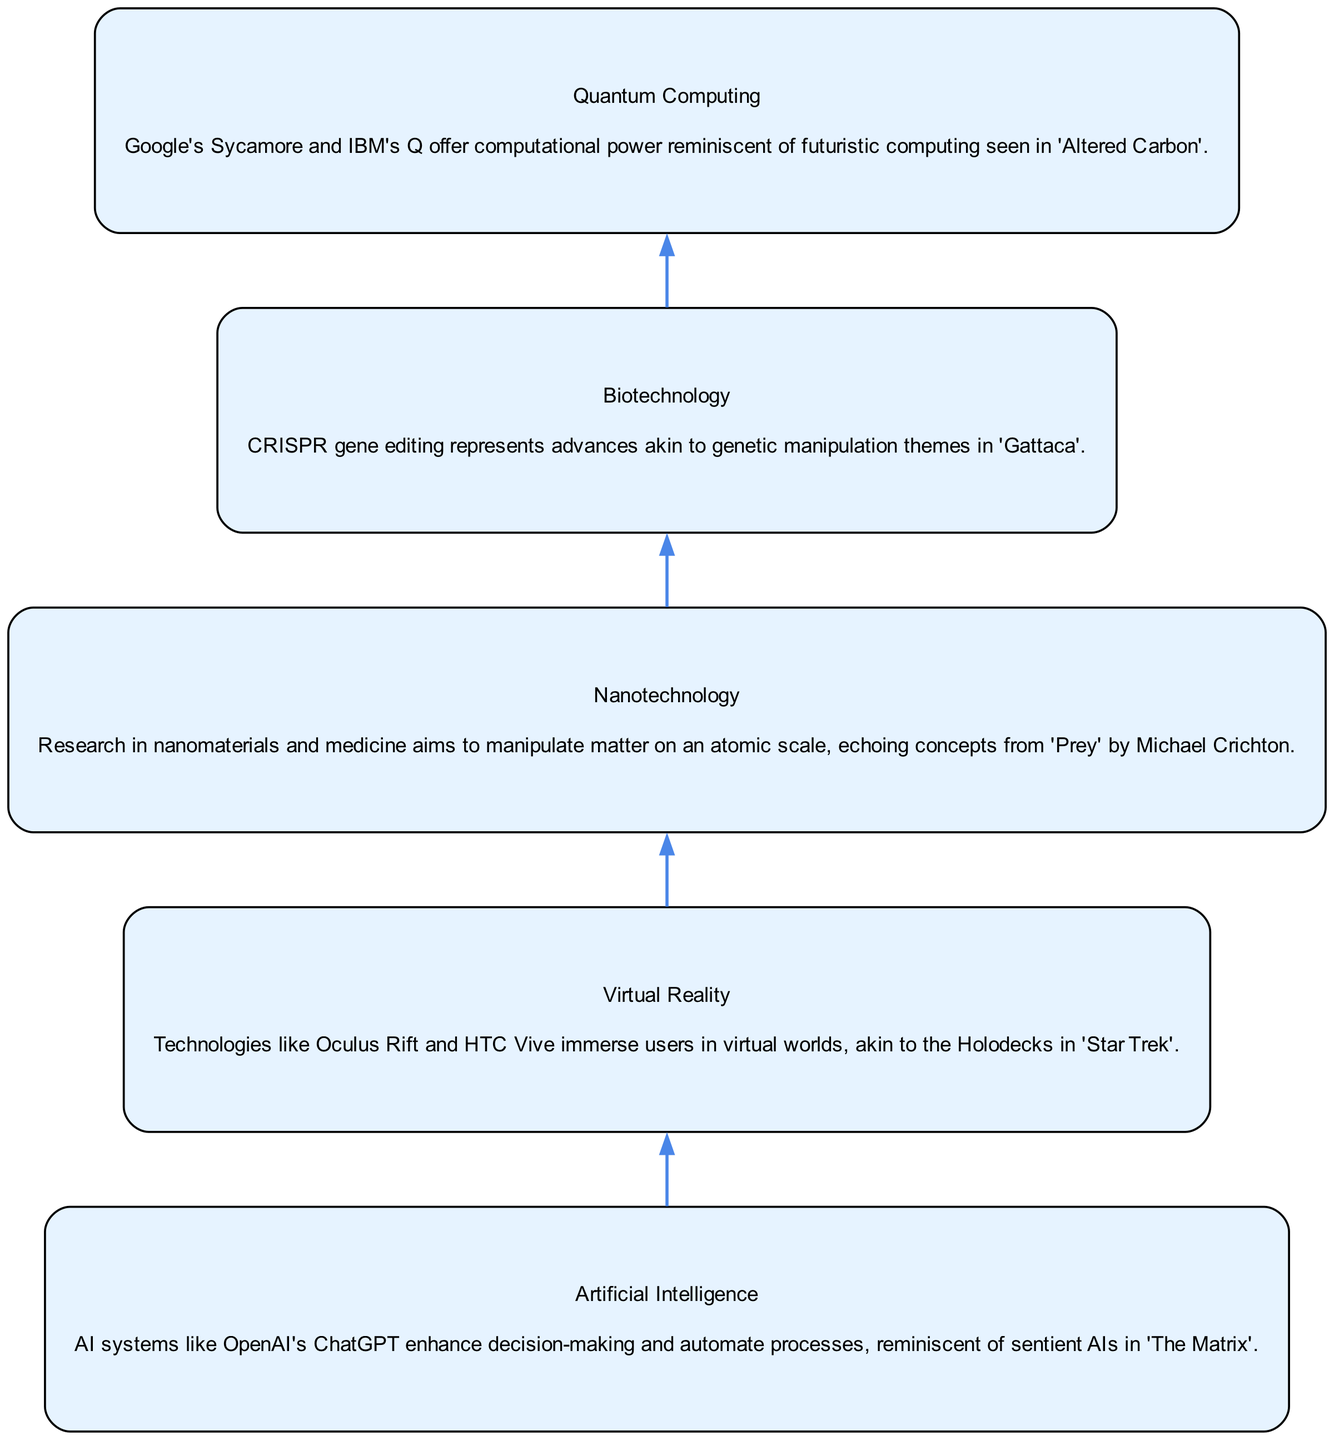What is the first technology listed in the diagram? The diagram's first node, which is at the bottom, represents "Artificial Intelligence." It's the first in the flow and doesn't have any connections leading into it.
Answer: Artificial Intelligence How many nodes are there in the diagram? Count the distinct technologies represented in the diagram. There are five nodes corresponding to the five advanced technologies listed.
Answer: 5 What technology follows Biotechnology in the progression? By following the connection from Biotechnology, the next node in the diagram is Quantum Computing. There is a direct edge leading from Biotechnology to Quantum Computing.
Answer: Quantum Computing Which two technologies are connected directly? The diagram shows various connections; for instance, Artificial Intelligence is directly connected to Virtual Reality, making them two technologies with a direct edge between them.
Answer: Artificial Intelligence and Virtual Reality What is the overall flow direction in the diagram? The diagram's structure illustrates a bottom-up flow, showing the progression of technologies from the base level of Artificial Intelligence to Quantum Computing at the top. This can be identified clearly by the arrangement of the nodes.
Answer: Bottom-Up Which technology is associated with the concept of manipulating matter on an atomic scale? The description for Nanotechnology in the diagram specifically mentions research that involves manipulating matter on an atomic scale. This defines its unique characteristic within the flow.
Answer: Nanotechnology How does the diagram structure reflect technological advancement? The progression in the diagram lays out that each technology builds upon or connects to the next, showcasing the advancement from Artificial Intelligence to Quantum Computing, indicating a hierarchical relationship illustrating growth and development in technology.
Answer: Hierarchical relationship What is the relationship between Virtual Reality and Quantum Computing in the diagram? Virtual Reality directly connects to Nanotechnology, which then connects to Biotechnology, leading to Quantum Computing, indicating a chain of relationships where one follows the other. The relationship can be traced through the connections in the flow.
Answer: Indirect connection through Nanotechnology and Biotechnology 